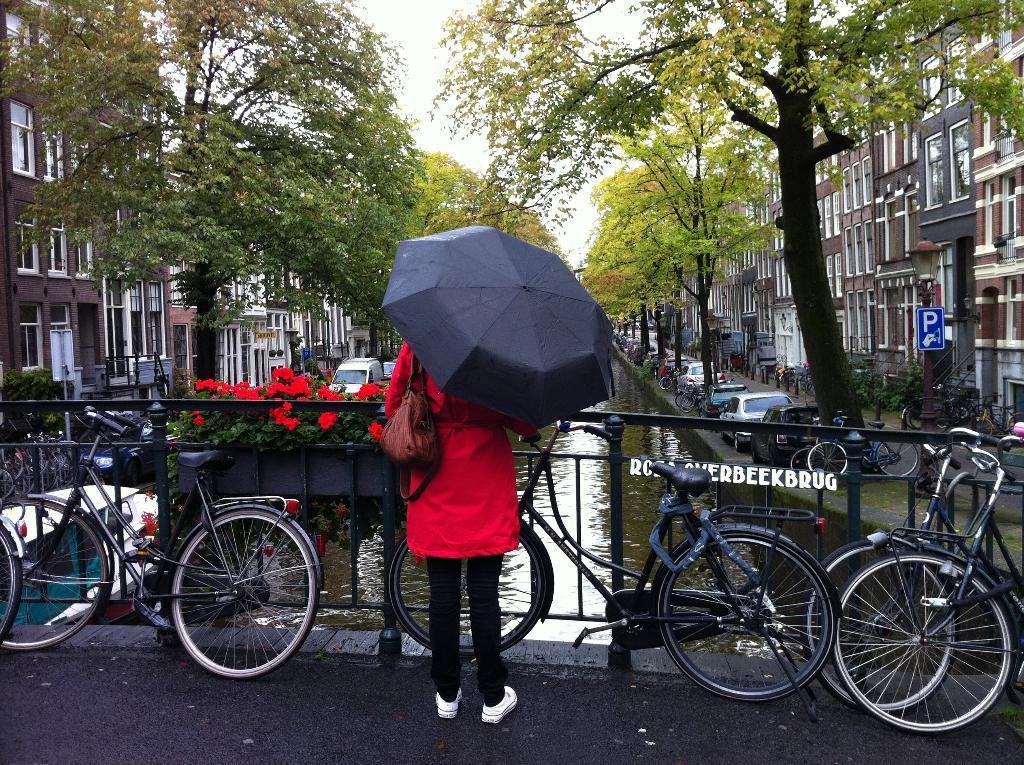How would you summarize this image in a sentence or two? In this image we can see this person wearing a red color jacket, bag and white color shoes is holding an umbrella. Here we can see these bicycle are parked on the bridge, here we can see the water, vehicles parked here, we can see flowers, plants, boards, houses, trees and the sky in the background. 